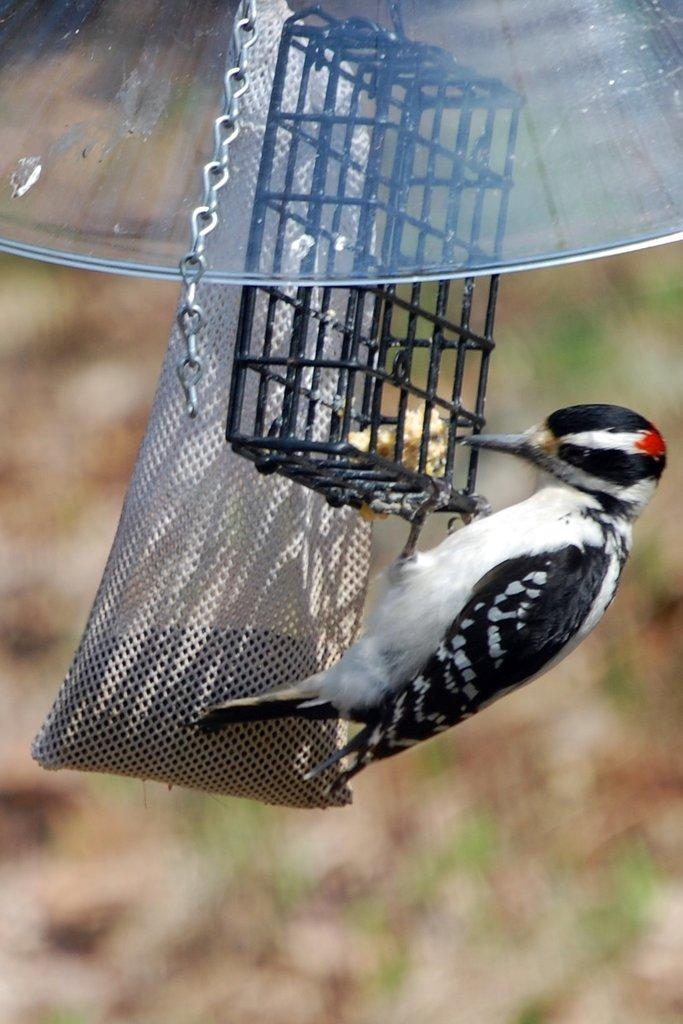What type of animal is in the image? There is a bird in the image. Where is the bird located in relation to the cage? The bird is beside a cage in the image. What other object can be seen in the image? There is a bag in the image. What type of material is present in the image? There is a chain in the image. How many cherries are on top of the pizzas in the image? There are no cherries or pizzas present in the image. 